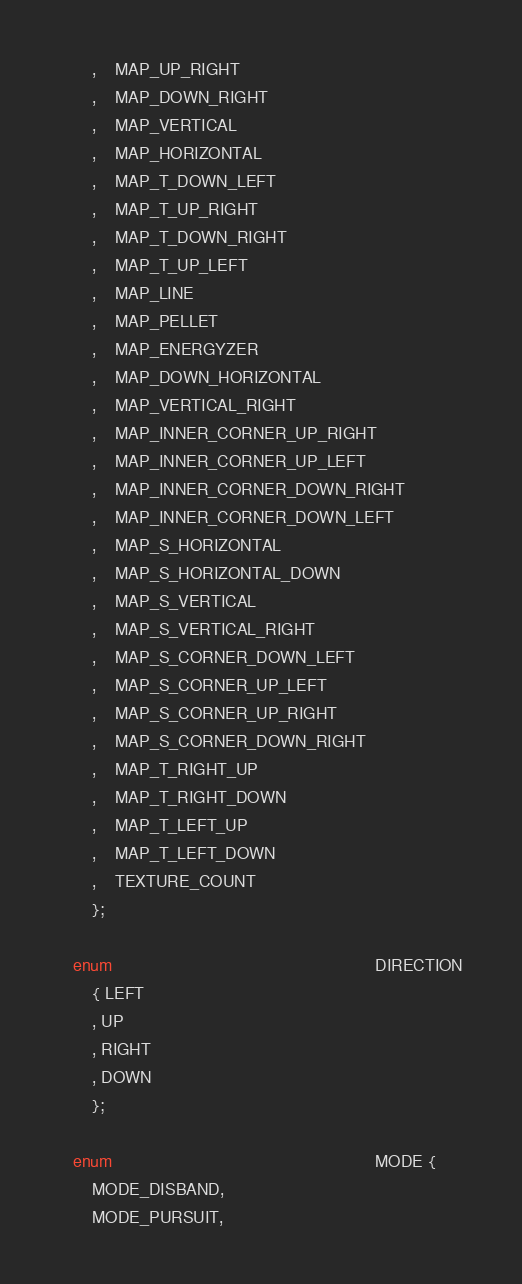Convert code to text. <code><loc_0><loc_0><loc_500><loc_500><_C_>		,	MAP_UP_RIGHT
		,	MAP_DOWN_RIGHT
		,	MAP_VERTICAL
		,	MAP_HORIZONTAL
		,	MAP_T_DOWN_LEFT
		,	MAP_T_UP_RIGHT
		,	MAP_T_DOWN_RIGHT
		,	MAP_T_UP_LEFT
		,	MAP_LINE
		,	MAP_PELLET
		,	MAP_ENERGYZER
		,	MAP_DOWN_HORIZONTAL
		,	MAP_VERTICAL_RIGHT
		,	MAP_INNER_CORNER_UP_RIGHT
		,	MAP_INNER_CORNER_UP_LEFT
		,	MAP_INNER_CORNER_DOWN_RIGHT
		,	MAP_INNER_CORNER_DOWN_LEFT
		,	MAP_S_HORIZONTAL
		,	MAP_S_HORIZONTAL_DOWN
		,	MAP_S_VERTICAL
		,	MAP_S_VERTICAL_RIGHT
		,	MAP_S_CORNER_DOWN_LEFT
		,	MAP_S_CORNER_UP_LEFT
		,	MAP_S_CORNER_UP_RIGHT
		,	MAP_S_CORNER_DOWN_RIGHT
		,	MAP_T_RIGHT_UP
		,	MAP_T_RIGHT_DOWN
		,	MAP_T_LEFT_UP
		,	MAP_T_LEFT_DOWN
		,	TEXTURE_COUNT
		};	
	
	enum														DIRECTION 
		{ LEFT
		, UP
		, RIGHT
		, DOWN
		};

	enum														MODE {
		MODE_DISBAND,
		MODE_PURSUIT,</code> 